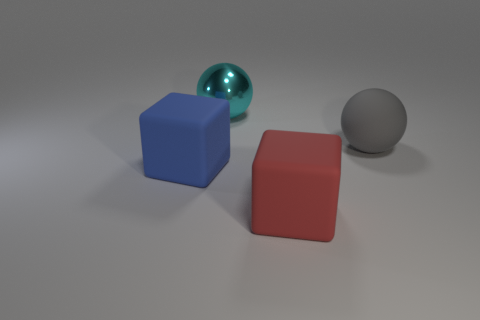Is there any other thing that has the same material as the cyan ball?
Provide a short and direct response. No. What number of tiny yellow cylinders have the same material as the large red block?
Make the answer very short. 0. How many shiny objects are either cubes or gray balls?
Your answer should be very brief. 0. There is a rubber thing that is in front of the big blue object; does it have the same shape as the big thing on the left side of the cyan object?
Offer a very short reply. Yes. There is a big matte thing that is both in front of the matte ball and on the right side of the blue matte object; what color is it?
Offer a very short reply. Red. What number of small things are either blue matte things or gray metal things?
Make the answer very short. 0. Are the cube behind the large red rubber object and the cyan sphere made of the same material?
Make the answer very short. No. What color is the rubber block that is right of the blue object?
Your response must be concise. Red. Are there any other balls of the same size as the rubber sphere?
Your response must be concise. Yes. What material is the cyan object that is the same size as the gray matte ball?
Offer a very short reply. Metal. 